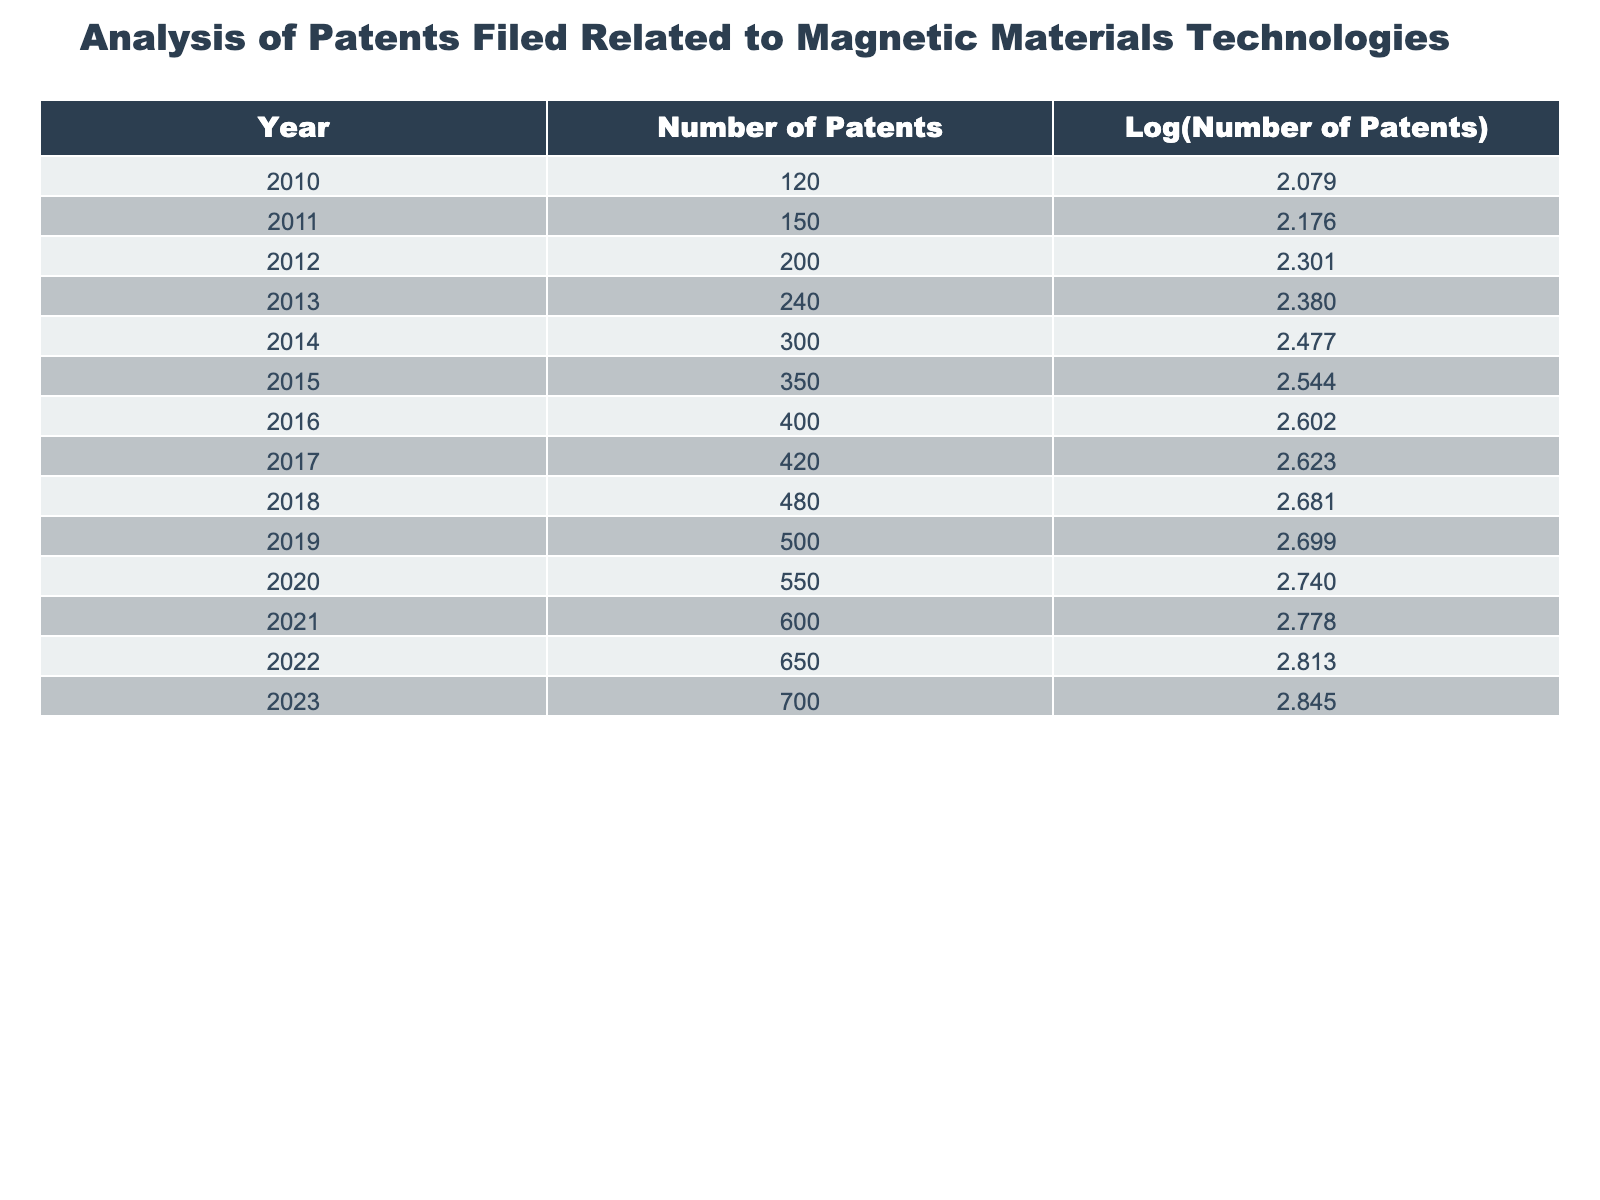What was the number of patents filed in 2013? The table indicates the number of patents filed in 2013 is explicitly listed as 240.
Answer: 240 What was the logarithmic value of the number of patents in 2020? The table shows that the logarithmic value corresponding to the number of patents filed in 2020 is 2.740.
Answer: 2.740 Which year saw the highest number of patents filed? The highest number of patents filed is 700, which occurred in 2023, as per the table data.
Answer: 2023 What is the average number of patents filed per year from 2010 to 2023? To find the average, sum the number of patents from 2010 to 2023: (120 + 150 + 200 + 240 + 300 + 350 + 400 + 420 + 480 + 500 + 550 + 600 + 650 + 700) = 5,120. There are 14 years from 2010 to 2023, so the average is 5,120 / 14 = 365.71.
Answer: 365.71 Did the number of patents filed increase every year from 2010 to 2023? Reviewing the data from the table, it shows that for each year from 2010 to 2023, the number of patents consistently increases without any drop.
Answer: Yes What was the total increase in the number of patents filed from 2010 to 2023? The total increase can be calculated as follows: 700 (in 2023) - 120 (in 2010) = 580. Thus, the total increase in the number of patents is 580.
Answer: 580 Was the logarithmic value of the number of patents filed in 2011 greater than 2.2? According to the table, the logarithmic value for 2011 was 2.176, which is less than 2.2.
Answer: No Which year had the closest number of patents to 500? By examining the list, 2019 had exactly 500 patents filed, making it the year closest to this figure.
Answer: 2019 